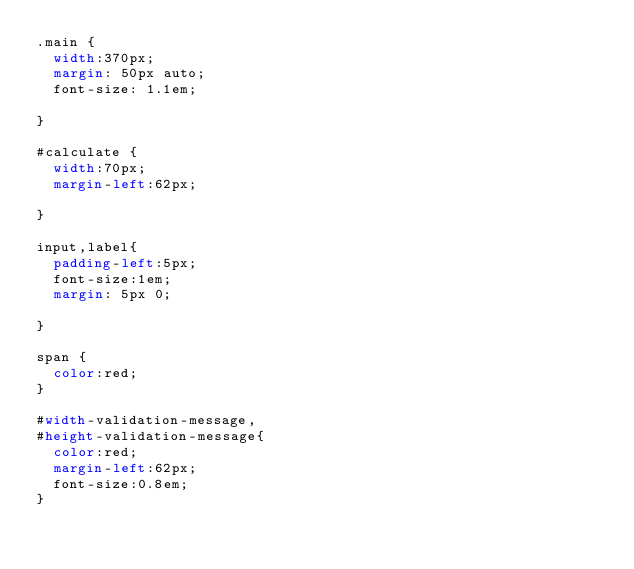Convert code to text. <code><loc_0><loc_0><loc_500><loc_500><_CSS_>.main {
  width:370px;
  margin: 50px auto;
  font-size: 1.1em;

}

#calculate {
  width:70px;
  margin-left:62px;

}

input,label{
  padding-left:5px;
  font-size:1em;
  margin: 5px 0;

}

span {
  color:red;
}

#width-validation-message,
#height-validation-message{
  color:red;
  margin-left:62px;
  font-size:0.8em;
}
</code> 